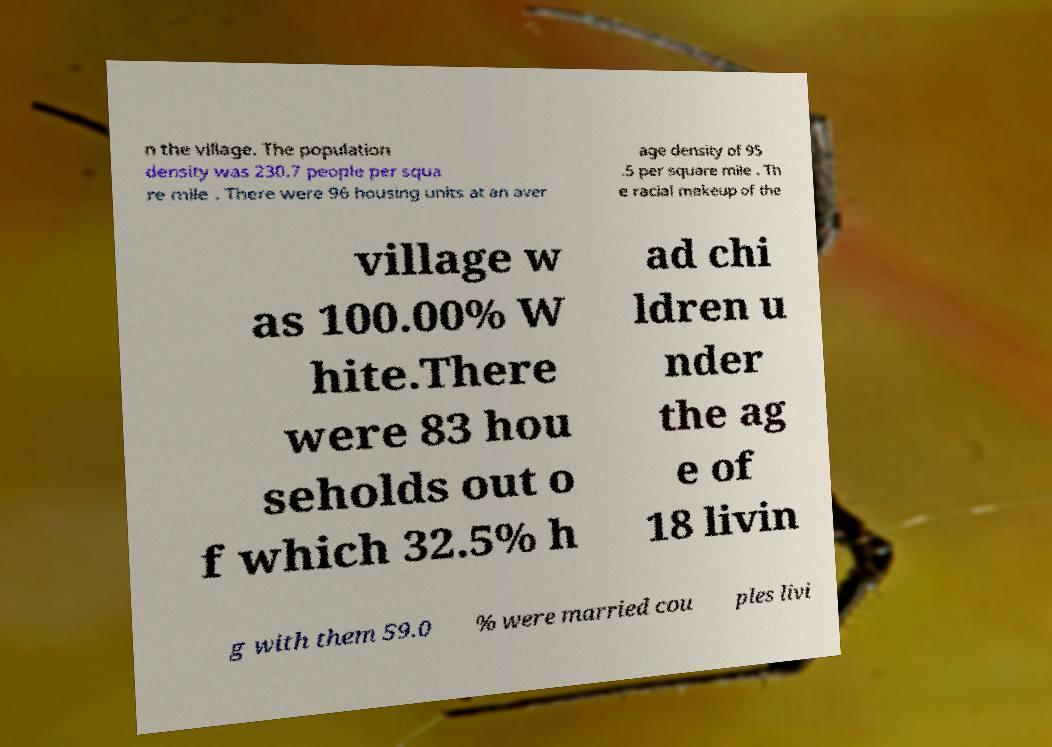Could you extract and type out the text from this image? n the village. The population density was 230.7 people per squa re mile . There were 96 housing units at an aver age density of 95 .5 per square mile . Th e racial makeup of the village w as 100.00% W hite.There were 83 hou seholds out o f which 32.5% h ad chi ldren u nder the ag e of 18 livin g with them 59.0 % were married cou ples livi 